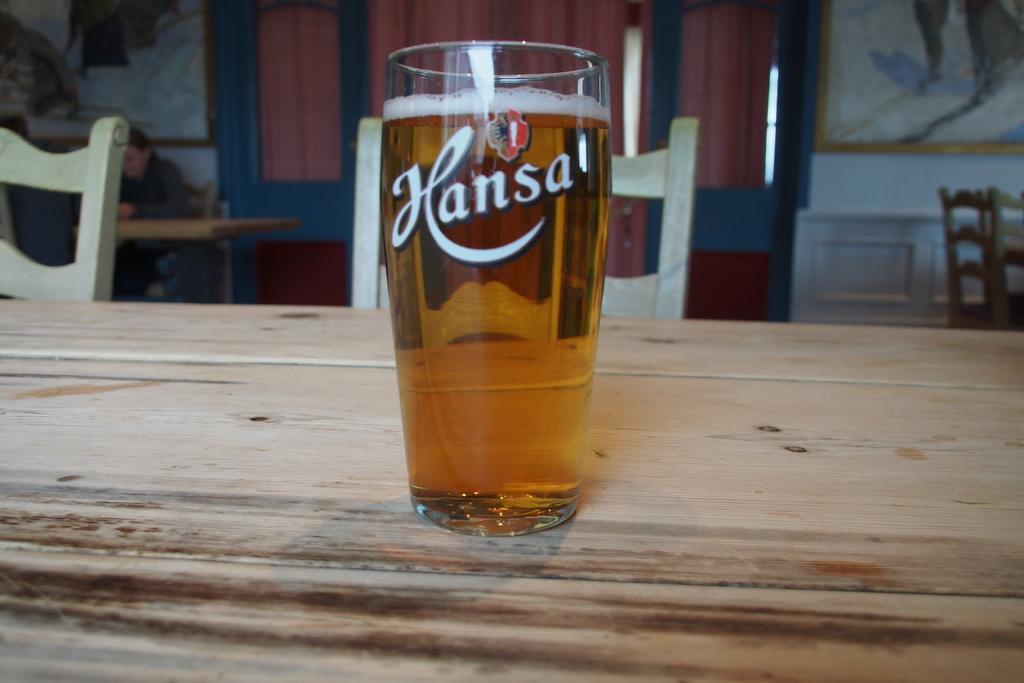Describe this image in one or two sentences. A glass of wine is on the table. There are chairs behind. 